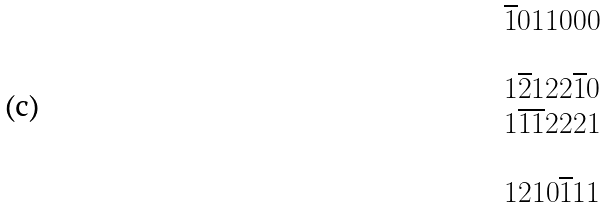<formula> <loc_0><loc_0><loc_500><loc_500>\begin{array} { l } \overline { 1 } 0 1 1 0 0 0 \\ \\ 1 \overline { 2 } 1 2 2 \overline { 1 } 0 \\ 1 \overline { 1 } \overline { 1 } 2 2 2 1 \\ \\ 1 2 1 0 \overline { 1 } 1 1 \end{array}</formula> 